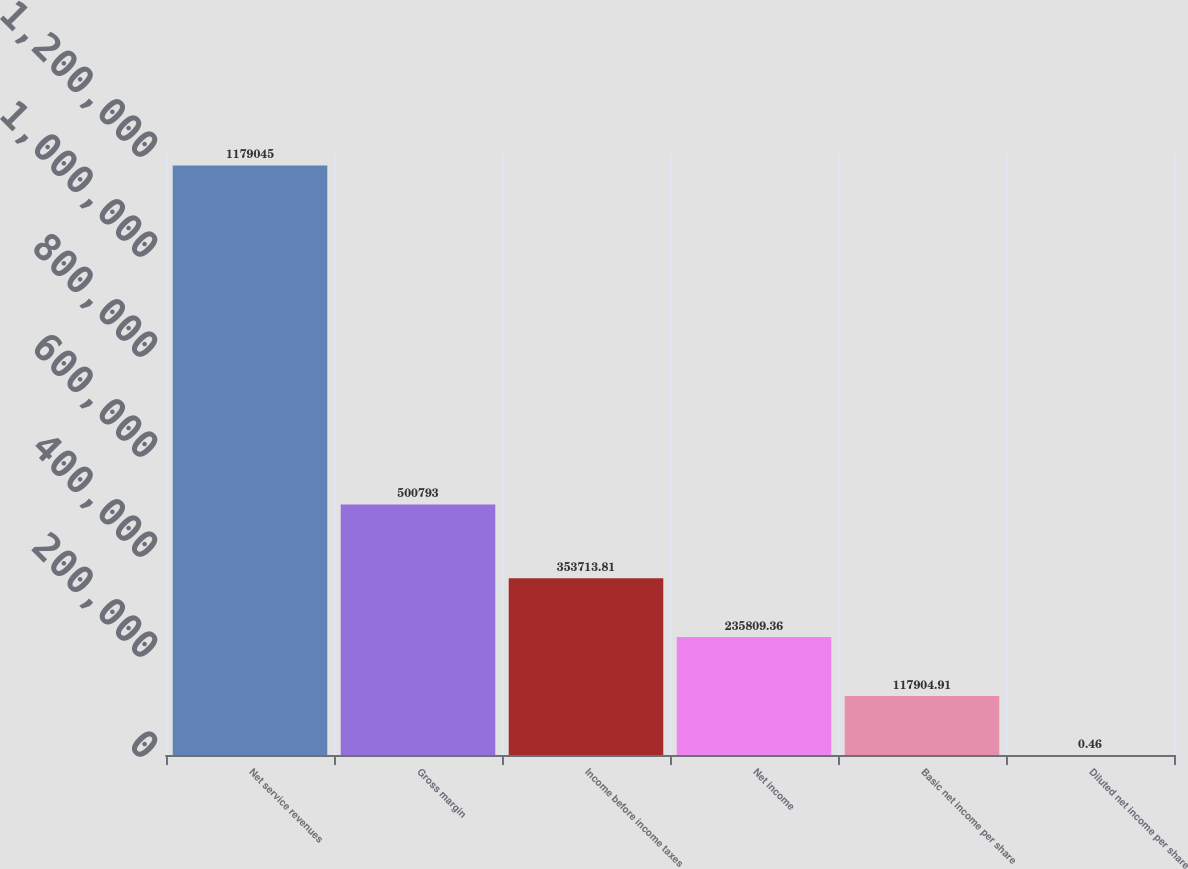Convert chart. <chart><loc_0><loc_0><loc_500><loc_500><bar_chart><fcel>Net service revenues<fcel>Gross margin<fcel>Income before income taxes<fcel>Net income<fcel>Basic net income per share<fcel>Diluted net income per share<nl><fcel>1.17904e+06<fcel>500793<fcel>353714<fcel>235809<fcel>117905<fcel>0.46<nl></chart> 